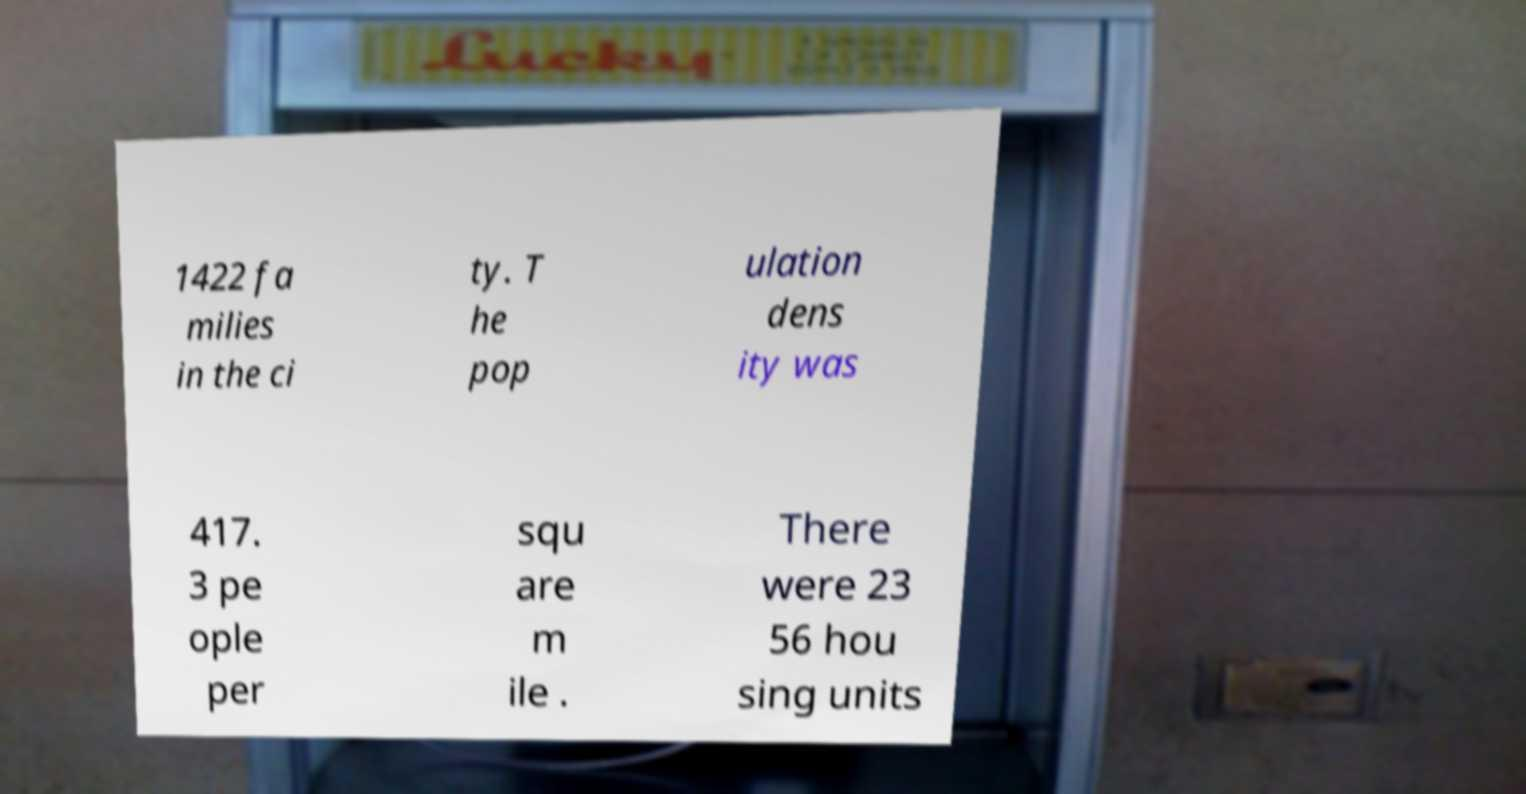Please read and relay the text visible in this image. What does it say? 1422 fa milies in the ci ty. T he pop ulation dens ity was 417. 3 pe ople per squ are m ile . There were 23 56 hou sing units 